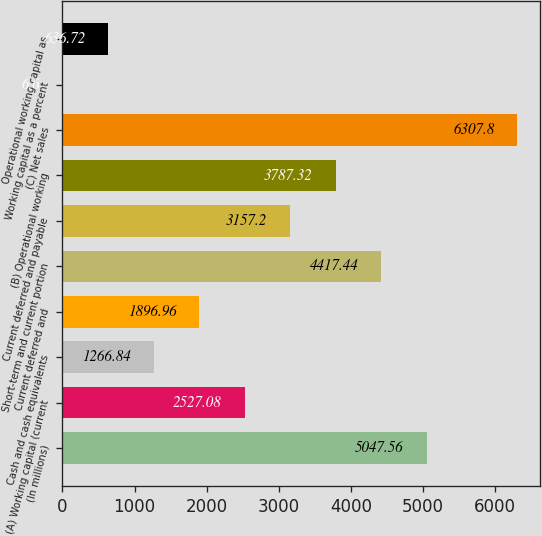Convert chart. <chart><loc_0><loc_0><loc_500><loc_500><bar_chart><fcel>(In millions)<fcel>(A) Working capital (current<fcel>Cash and cash equivalents<fcel>Current deferred and<fcel>Short-term and current portion<fcel>Current deferred and payable<fcel>(B) Operational working<fcel>(C) Net sales<fcel>Working capital as a percent<fcel>Operational working capital as<nl><fcel>5047.56<fcel>2527.08<fcel>1266.84<fcel>1896.96<fcel>4417.44<fcel>3157.2<fcel>3787.32<fcel>6307.8<fcel>6.6<fcel>636.72<nl></chart> 